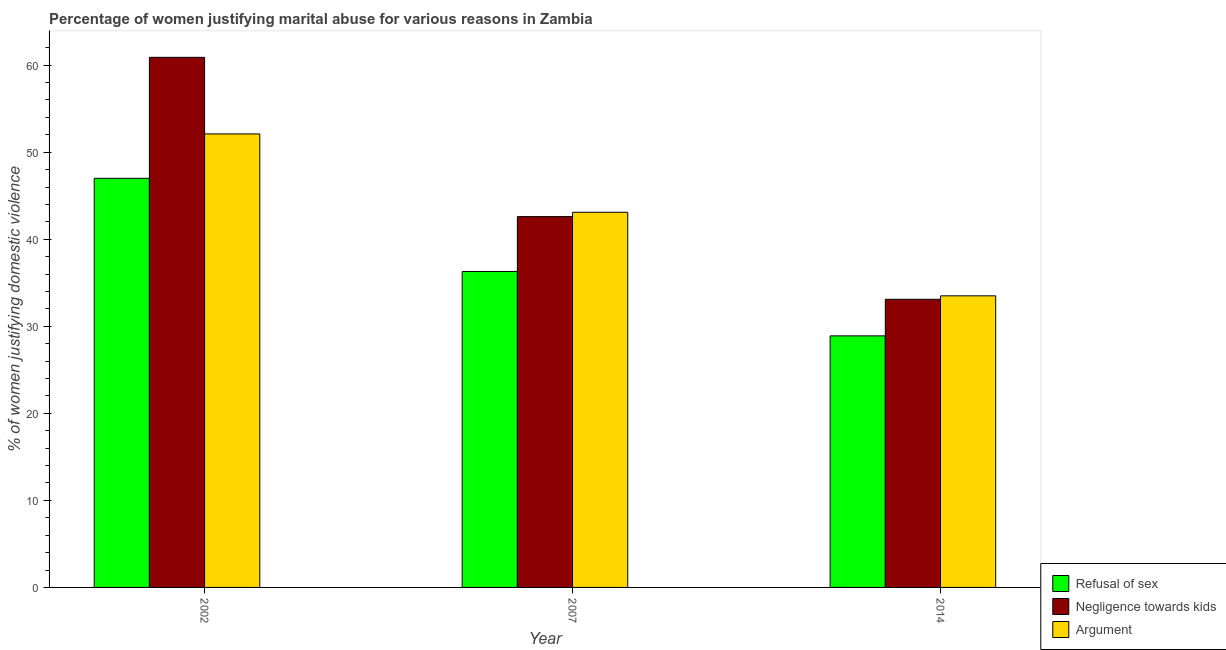What is the label of the 3rd group of bars from the left?
Your response must be concise. 2014. In how many cases, is the number of bars for a given year not equal to the number of legend labels?
Keep it short and to the point. 0. What is the percentage of women justifying domestic violence due to negligence towards kids in 2002?
Give a very brief answer. 60.9. Across all years, what is the maximum percentage of women justifying domestic violence due to negligence towards kids?
Provide a succinct answer. 60.9. Across all years, what is the minimum percentage of women justifying domestic violence due to negligence towards kids?
Make the answer very short. 33.1. In which year was the percentage of women justifying domestic violence due to arguments maximum?
Provide a succinct answer. 2002. In which year was the percentage of women justifying domestic violence due to negligence towards kids minimum?
Give a very brief answer. 2014. What is the total percentage of women justifying domestic violence due to refusal of sex in the graph?
Offer a terse response. 112.2. What is the difference between the percentage of women justifying domestic violence due to arguments in 2007 and that in 2014?
Your answer should be very brief. 9.6. What is the difference between the percentage of women justifying domestic violence due to negligence towards kids in 2014 and the percentage of women justifying domestic violence due to refusal of sex in 2002?
Offer a terse response. -27.8. What is the average percentage of women justifying domestic violence due to negligence towards kids per year?
Keep it short and to the point. 45.53. What is the ratio of the percentage of women justifying domestic violence due to refusal of sex in 2002 to that in 2014?
Provide a short and direct response. 1.63. Is the difference between the percentage of women justifying domestic violence due to refusal of sex in 2002 and 2007 greater than the difference between the percentage of women justifying domestic violence due to negligence towards kids in 2002 and 2007?
Provide a short and direct response. No. What is the difference between the highest and the second highest percentage of women justifying domestic violence due to refusal of sex?
Keep it short and to the point. 10.7. What does the 1st bar from the left in 2002 represents?
Ensure brevity in your answer.  Refusal of sex. What does the 1st bar from the right in 2002 represents?
Keep it short and to the point. Argument. Is it the case that in every year, the sum of the percentage of women justifying domestic violence due to refusal of sex and percentage of women justifying domestic violence due to negligence towards kids is greater than the percentage of women justifying domestic violence due to arguments?
Keep it short and to the point. Yes. Are all the bars in the graph horizontal?
Offer a terse response. No. Does the graph contain any zero values?
Give a very brief answer. No. Where does the legend appear in the graph?
Make the answer very short. Bottom right. How many legend labels are there?
Keep it short and to the point. 3. How are the legend labels stacked?
Provide a short and direct response. Vertical. What is the title of the graph?
Make the answer very short. Percentage of women justifying marital abuse for various reasons in Zambia. Does "ICT services" appear as one of the legend labels in the graph?
Keep it short and to the point. No. What is the label or title of the X-axis?
Offer a terse response. Year. What is the label or title of the Y-axis?
Your answer should be compact. % of women justifying domestic violence. What is the % of women justifying domestic violence in Negligence towards kids in 2002?
Offer a very short reply. 60.9. What is the % of women justifying domestic violence of Argument in 2002?
Offer a very short reply. 52.1. What is the % of women justifying domestic violence of Refusal of sex in 2007?
Provide a short and direct response. 36.3. What is the % of women justifying domestic violence in Negligence towards kids in 2007?
Provide a succinct answer. 42.6. What is the % of women justifying domestic violence of Argument in 2007?
Offer a very short reply. 43.1. What is the % of women justifying domestic violence in Refusal of sex in 2014?
Provide a short and direct response. 28.9. What is the % of women justifying domestic violence of Negligence towards kids in 2014?
Provide a short and direct response. 33.1. What is the % of women justifying domestic violence of Argument in 2014?
Your answer should be compact. 33.5. Across all years, what is the maximum % of women justifying domestic violence of Refusal of sex?
Your response must be concise. 47. Across all years, what is the maximum % of women justifying domestic violence in Negligence towards kids?
Make the answer very short. 60.9. Across all years, what is the maximum % of women justifying domestic violence of Argument?
Provide a succinct answer. 52.1. Across all years, what is the minimum % of women justifying domestic violence in Refusal of sex?
Make the answer very short. 28.9. Across all years, what is the minimum % of women justifying domestic violence of Negligence towards kids?
Provide a short and direct response. 33.1. Across all years, what is the minimum % of women justifying domestic violence in Argument?
Provide a succinct answer. 33.5. What is the total % of women justifying domestic violence in Refusal of sex in the graph?
Give a very brief answer. 112.2. What is the total % of women justifying domestic violence in Negligence towards kids in the graph?
Give a very brief answer. 136.6. What is the total % of women justifying domestic violence in Argument in the graph?
Make the answer very short. 128.7. What is the difference between the % of women justifying domestic violence in Refusal of sex in 2002 and that in 2007?
Provide a succinct answer. 10.7. What is the difference between the % of women justifying domestic violence of Negligence towards kids in 2002 and that in 2007?
Your response must be concise. 18.3. What is the difference between the % of women justifying domestic violence in Refusal of sex in 2002 and that in 2014?
Give a very brief answer. 18.1. What is the difference between the % of women justifying domestic violence in Negligence towards kids in 2002 and that in 2014?
Provide a short and direct response. 27.8. What is the difference between the % of women justifying domestic violence in Argument in 2002 and that in 2014?
Your answer should be very brief. 18.6. What is the difference between the % of women justifying domestic violence of Refusal of sex in 2002 and the % of women justifying domestic violence of Negligence towards kids in 2007?
Keep it short and to the point. 4.4. What is the difference between the % of women justifying domestic violence of Refusal of sex in 2002 and the % of women justifying domestic violence of Argument in 2007?
Your answer should be compact. 3.9. What is the difference between the % of women justifying domestic violence of Refusal of sex in 2002 and the % of women justifying domestic violence of Negligence towards kids in 2014?
Ensure brevity in your answer.  13.9. What is the difference between the % of women justifying domestic violence of Refusal of sex in 2002 and the % of women justifying domestic violence of Argument in 2014?
Provide a succinct answer. 13.5. What is the difference between the % of women justifying domestic violence in Negligence towards kids in 2002 and the % of women justifying domestic violence in Argument in 2014?
Provide a succinct answer. 27.4. What is the difference between the % of women justifying domestic violence in Refusal of sex in 2007 and the % of women justifying domestic violence in Negligence towards kids in 2014?
Offer a very short reply. 3.2. What is the difference between the % of women justifying domestic violence in Refusal of sex in 2007 and the % of women justifying domestic violence in Argument in 2014?
Keep it short and to the point. 2.8. What is the average % of women justifying domestic violence of Refusal of sex per year?
Ensure brevity in your answer.  37.4. What is the average % of women justifying domestic violence of Negligence towards kids per year?
Ensure brevity in your answer.  45.53. What is the average % of women justifying domestic violence in Argument per year?
Make the answer very short. 42.9. In the year 2007, what is the difference between the % of women justifying domestic violence in Refusal of sex and % of women justifying domestic violence in Argument?
Offer a very short reply. -6.8. In the year 2007, what is the difference between the % of women justifying domestic violence of Negligence towards kids and % of women justifying domestic violence of Argument?
Offer a terse response. -0.5. In the year 2014, what is the difference between the % of women justifying domestic violence in Refusal of sex and % of women justifying domestic violence in Argument?
Offer a very short reply. -4.6. What is the ratio of the % of women justifying domestic violence of Refusal of sex in 2002 to that in 2007?
Make the answer very short. 1.29. What is the ratio of the % of women justifying domestic violence of Negligence towards kids in 2002 to that in 2007?
Give a very brief answer. 1.43. What is the ratio of the % of women justifying domestic violence in Argument in 2002 to that in 2007?
Your response must be concise. 1.21. What is the ratio of the % of women justifying domestic violence of Refusal of sex in 2002 to that in 2014?
Ensure brevity in your answer.  1.63. What is the ratio of the % of women justifying domestic violence of Negligence towards kids in 2002 to that in 2014?
Offer a very short reply. 1.84. What is the ratio of the % of women justifying domestic violence of Argument in 2002 to that in 2014?
Provide a succinct answer. 1.56. What is the ratio of the % of women justifying domestic violence of Refusal of sex in 2007 to that in 2014?
Your answer should be very brief. 1.26. What is the ratio of the % of women justifying domestic violence of Negligence towards kids in 2007 to that in 2014?
Give a very brief answer. 1.29. What is the ratio of the % of women justifying domestic violence of Argument in 2007 to that in 2014?
Your response must be concise. 1.29. What is the difference between the highest and the second highest % of women justifying domestic violence of Refusal of sex?
Your answer should be very brief. 10.7. What is the difference between the highest and the second highest % of women justifying domestic violence in Negligence towards kids?
Your answer should be compact. 18.3. What is the difference between the highest and the second highest % of women justifying domestic violence in Argument?
Keep it short and to the point. 9. What is the difference between the highest and the lowest % of women justifying domestic violence in Negligence towards kids?
Your response must be concise. 27.8. 